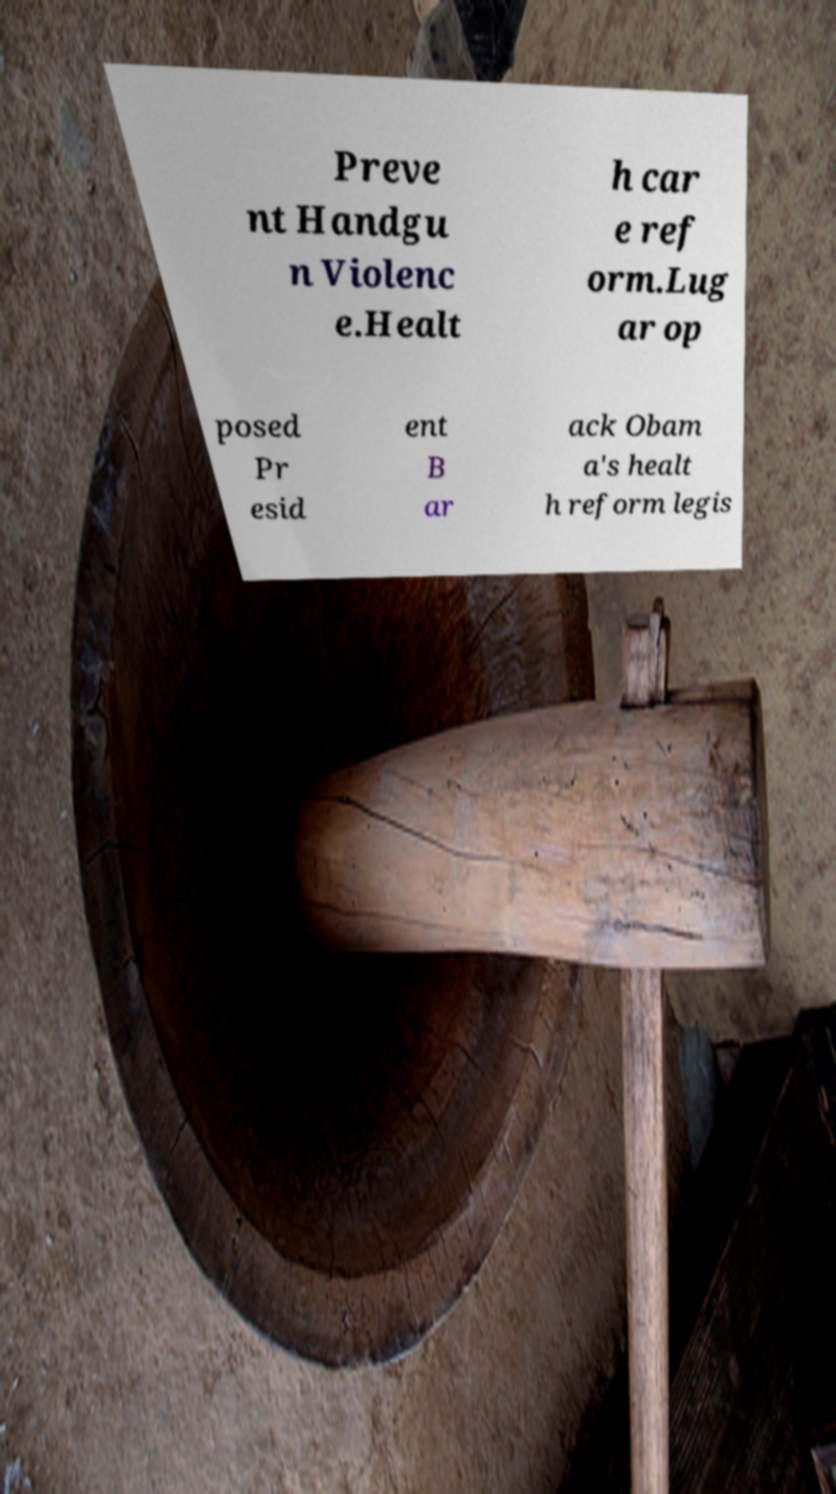I need the written content from this picture converted into text. Can you do that? Preve nt Handgu n Violenc e.Healt h car e ref orm.Lug ar op posed Pr esid ent B ar ack Obam a's healt h reform legis 